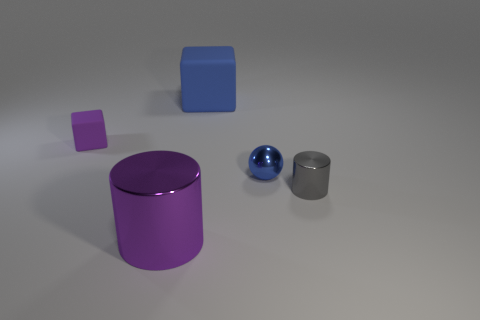Add 4 tiny shiny cylinders. How many objects exist? 9 Subtract 1 cubes. How many cubes are left? 1 Subtract all gray cylinders. How many cylinders are left? 1 Subtract all purple blocks. Subtract all red spheres. How many blocks are left? 1 Subtract all small gray cylinders. Subtract all tiny purple objects. How many objects are left? 3 Add 3 tiny matte objects. How many tiny matte objects are left? 4 Add 2 large purple metal things. How many large purple metal things exist? 3 Subtract 0 red spheres. How many objects are left? 5 Subtract all cylinders. How many objects are left? 3 